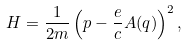<formula> <loc_0><loc_0><loc_500><loc_500>H = \frac { 1 } { 2 m } \left ( { p } - \frac { e } { c } { A } ( { q } ) \right ) ^ { 2 } ,</formula> 